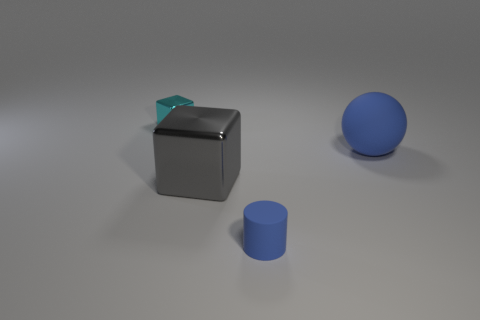What kind of material do the objects appear to be made of, and what does their appearance suggest about the setting? The objects in the image seem to be made of a smooth, matte material with a slight shine, resembling perhaps a hard plastic or metal. The uniform lighting, soft shadows, and an absence of any distinct background features suggest that these objects might be placed in a controlled environment, possibly for a product display or a 3D rendering demonstration. 